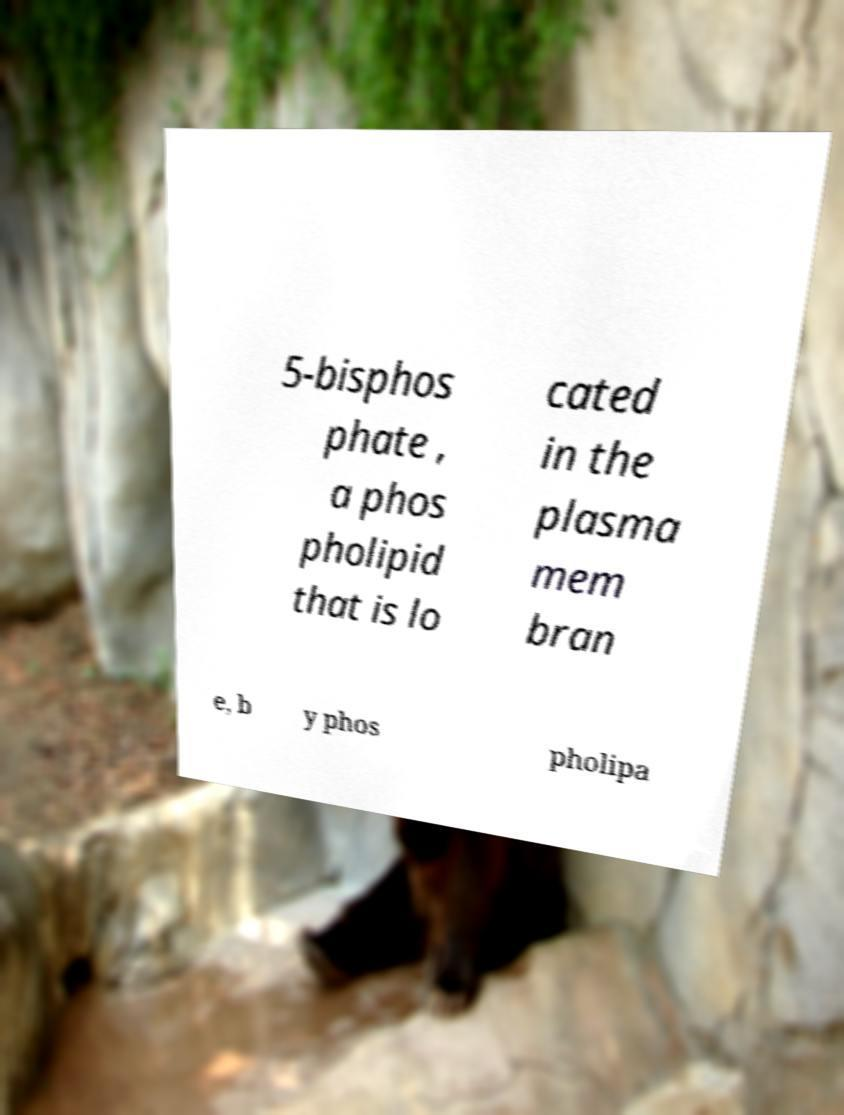Please identify and transcribe the text found in this image. 5-bisphos phate , a phos pholipid that is lo cated in the plasma mem bran e, b y phos pholipa 